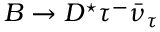Convert formula to latex. <formula><loc_0><loc_0><loc_500><loc_500>B \to D ^ { ^ { * } } \tau ^ { - } \bar { \nu } _ { \tau }</formula> 